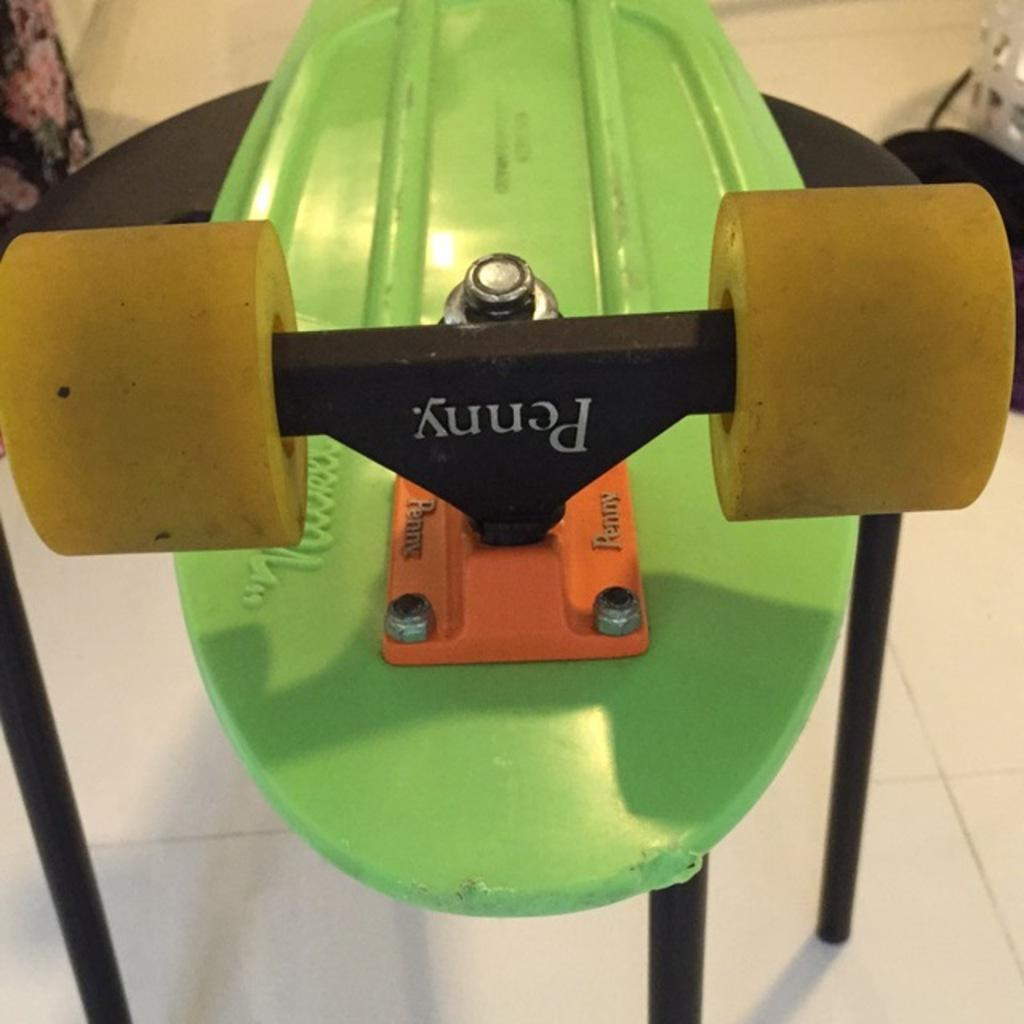What type of object is in the image that is related to exercise? There is an exercise equipment in the image. Where is the exercise equipment located? The exercise equipment is placed on the floor. What else can be seen on the left side of the image? There appears to be a cloth on the left side of the image. What type of lettuce is visible on the exercise equipment in the image? There is no lettuce present in the image; it features exercise equipment and a cloth. 